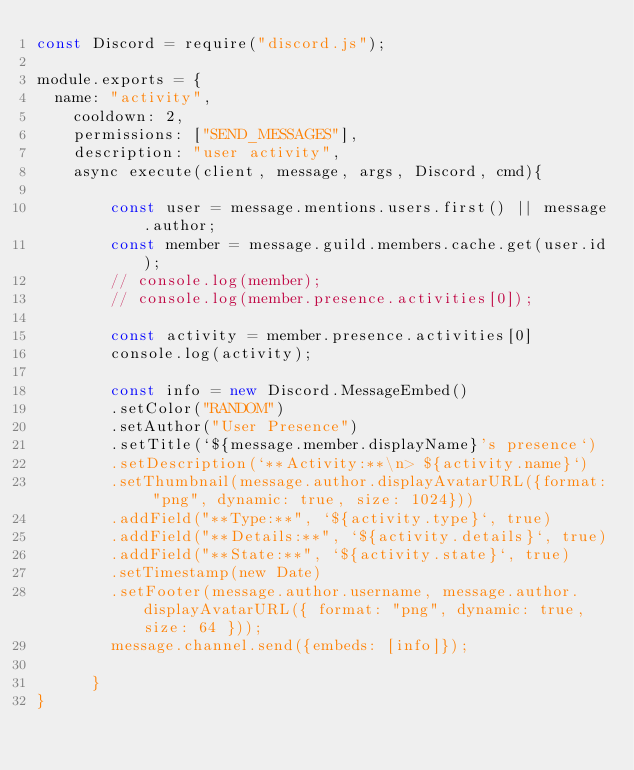Convert code to text. <code><loc_0><loc_0><loc_500><loc_500><_JavaScript_>const Discord = require("discord.js");

module.exports = {
  name: "activity",
    cooldown: 2,
    permissions: ["SEND_MESSAGES"],
    description: "user activity",
    async execute(client, message, args, Discord, cmd){

        const user = message.mentions.users.first() || message.author;
        const member = message.guild.members.cache.get(user.id);
        // console.log(member);
        // console.log(member.presence.activities[0]);

        const activity = member.presence.activities[0]
        console.log(activity);

        const info = new Discord.MessageEmbed()
        .setColor("RANDOM")
        .setAuthor("User Presence")
        .setTitle(`${message.member.displayName}'s presence`)
        .setDescription(`**Activity:**\n> ${activity.name}`)
        .setThumbnail(message.author.displayAvatarURL({format: "png", dynamic: true, size: 1024}))
        .addField("**Type:**", `${activity.type}`, true)
        .addField("**Details:**", `${activity.details}`, true)
        .addField("**State:**", `${activity.state}`, true)
        .setTimestamp(new Date)
        .setFooter(message.author.username, message.author.displayAvatarURL({ format: "png", dynamic: true, size: 64 }));
        message.channel.send({embeds: [info]});
        
      }
}</code> 